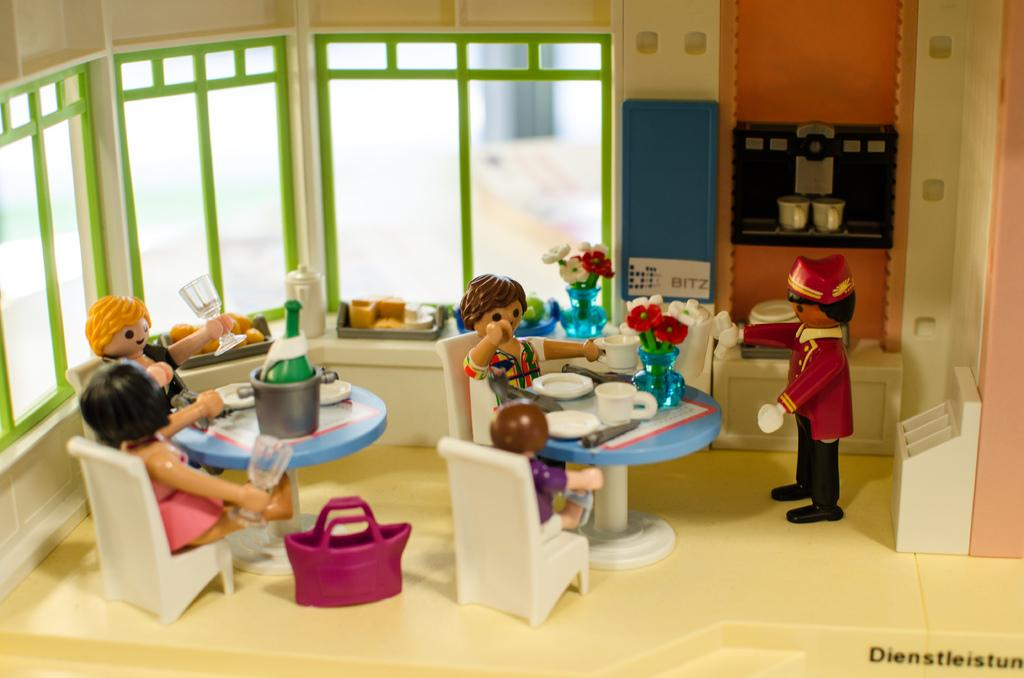What objects are present in the image? There are toys in the image. Where are the toys located? The toys are sitting on chairs. What type of notebook is being used by the toys in the image? There is no notebook present in the image; it only features toys sitting on chairs. 